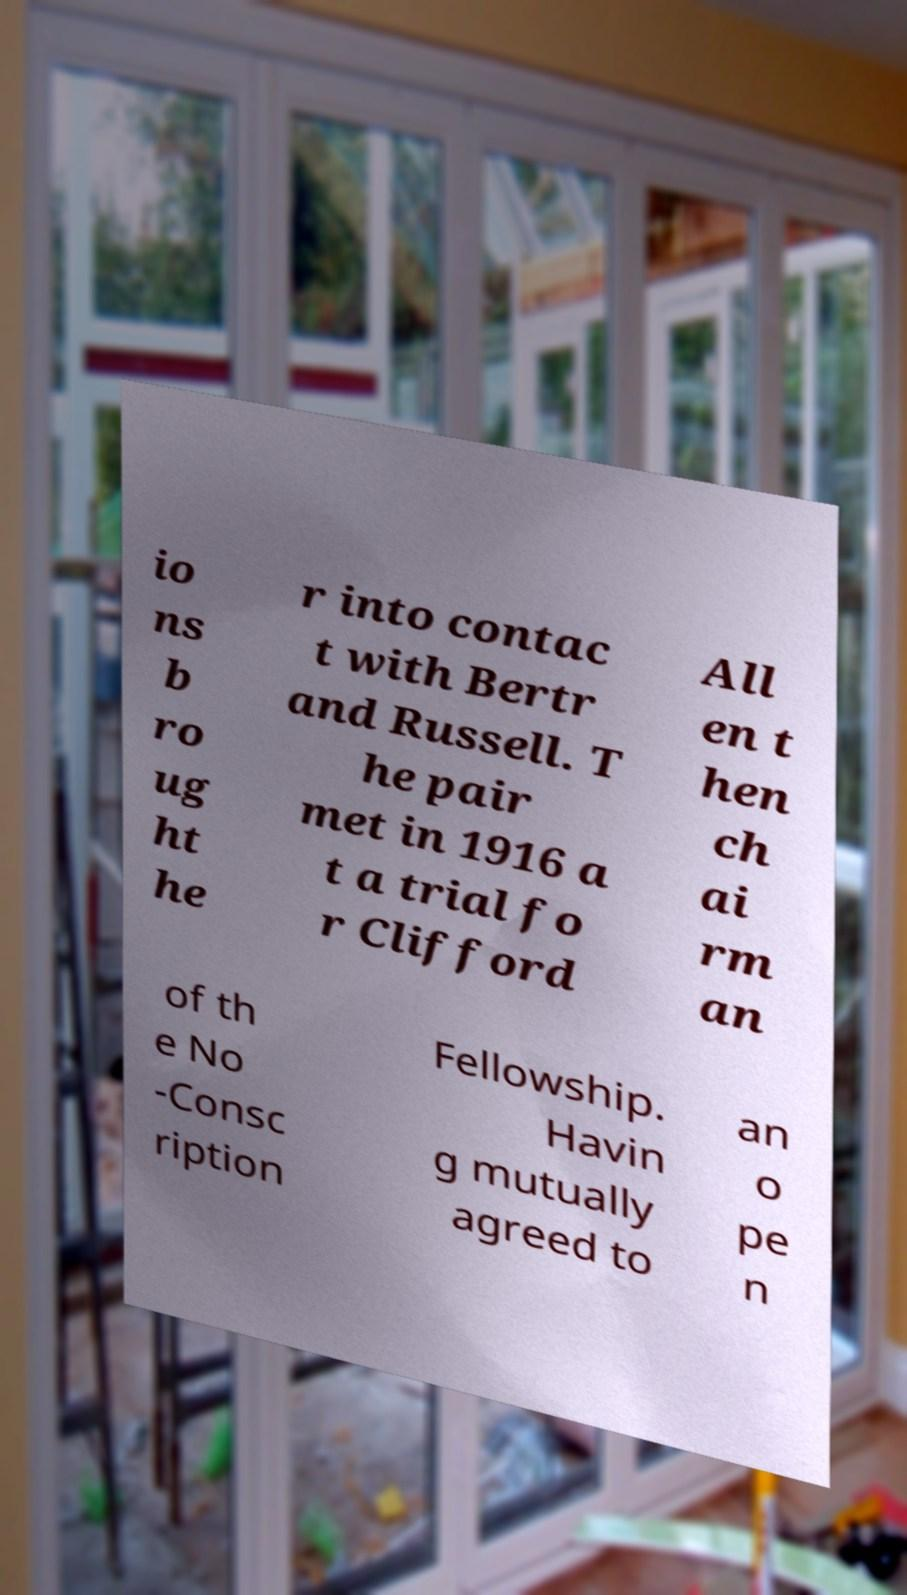Could you assist in decoding the text presented in this image and type it out clearly? io ns b ro ug ht he r into contac t with Bertr and Russell. T he pair met in 1916 a t a trial fo r Clifford All en t hen ch ai rm an of th e No -Consc ription Fellowship. Havin g mutually agreed to an o pe n 